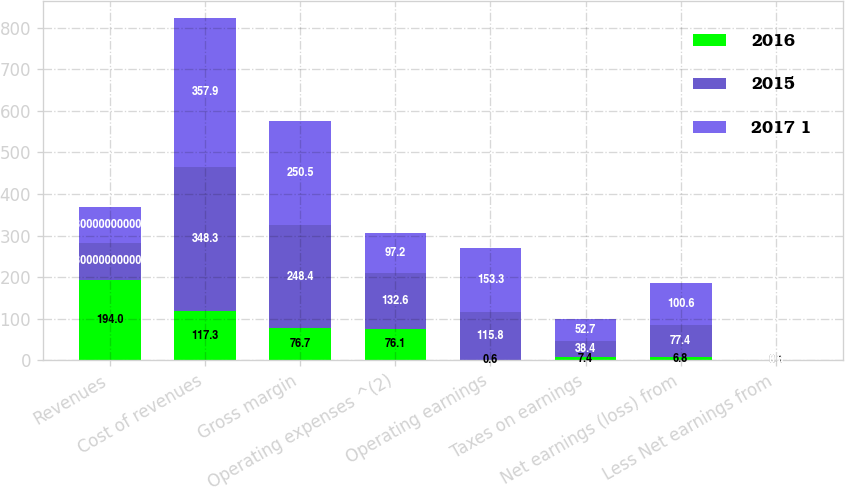<chart> <loc_0><loc_0><loc_500><loc_500><stacked_bar_chart><ecel><fcel>Revenues<fcel>Cost of revenues<fcel>Gross margin<fcel>Operating expenses ^(2)<fcel>Operating earnings<fcel>Taxes on earnings<fcel>Net earnings (loss) from<fcel>Less Net earnings from<nl><fcel>2016<fcel>194<fcel>117.3<fcel>76.7<fcel>76.1<fcel>0.6<fcel>7.4<fcel>6.8<fcel>0.1<nl><fcel>2015<fcel>87.3<fcel>348.3<fcel>248.4<fcel>132.6<fcel>115.8<fcel>38.4<fcel>77.4<fcel>0.5<nl><fcel>2017 1<fcel>87.3<fcel>357.9<fcel>250.5<fcel>97.2<fcel>153.3<fcel>52.7<fcel>100.6<fcel>0.7<nl></chart> 